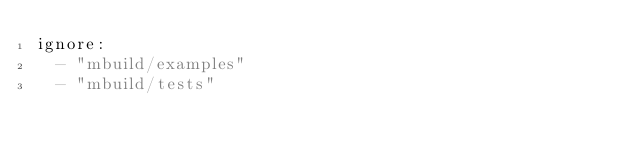<code> <loc_0><loc_0><loc_500><loc_500><_YAML_>ignore:
  - "mbuild/examples"
  - "mbuild/tests"
</code> 